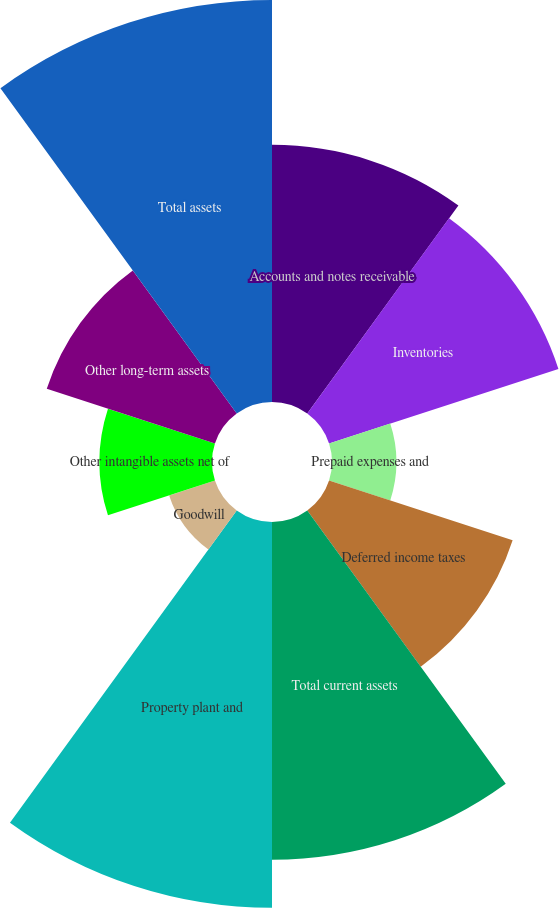Convert chart to OTSL. <chart><loc_0><loc_0><loc_500><loc_500><pie_chart><fcel>Accounts and notes receivable<fcel>Inventories<fcel>Prepaid expenses and<fcel>Deferred income taxes<fcel>Total current assets<fcel>Property plant and<fcel>Goodwill<fcel>Other intangible assets net of<fcel>Other long-term assets<fcel>Total assets<nl><fcel>11.59%<fcel>10.87%<fcel>2.9%<fcel>8.7%<fcel>15.22%<fcel>17.39%<fcel>2.17%<fcel>5.07%<fcel>7.97%<fcel>18.12%<nl></chart> 